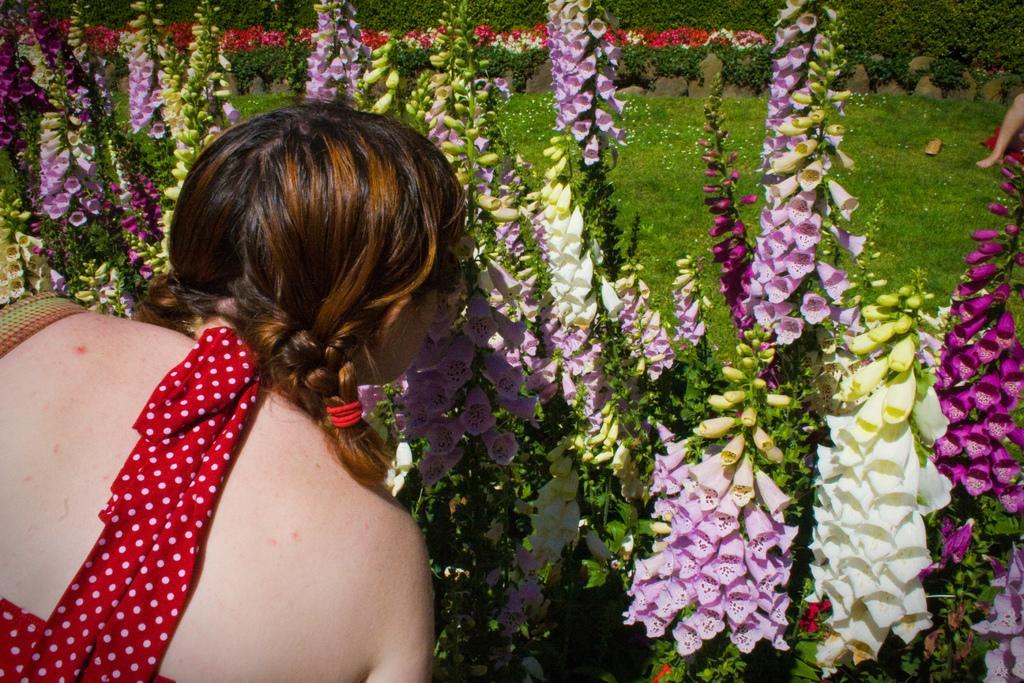In one or two sentences, can you explain what this image depicts? In this image we can see there are plants and flowers. And there is the person near the flowers. At the back we can see the person's leg and grass. 